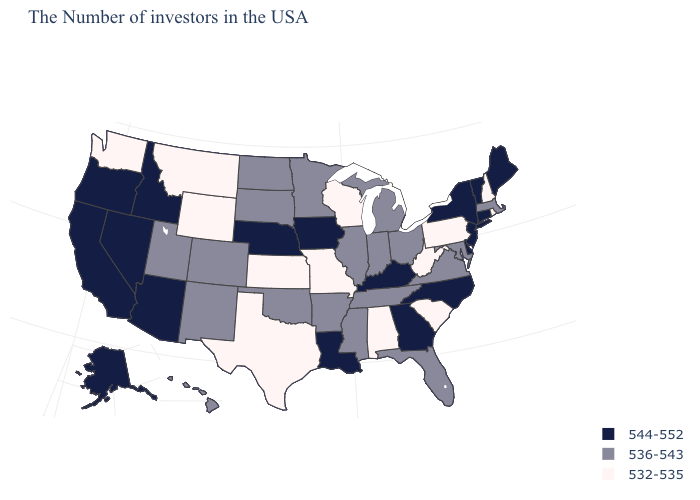Name the states that have a value in the range 532-535?
Answer briefly. Rhode Island, New Hampshire, Pennsylvania, South Carolina, West Virginia, Alabama, Wisconsin, Missouri, Kansas, Texas, Wyoming, Montana, Washington. What is the value of Wisconsin?
Concise answer only. 532-535. Among the states that border Maryland , which have the highest value?
Quick response, please. Delaware. Name the states that have a value in the range 544-552?
Answer briefly. Maine, Vermont, Connecticut, New York, New Jersey, Delaware, North Carolina, Georgia, Kentucky, Louisiana, Iowa, Nebraska, Arizona, Idaho, Nevada, California, Oregon, Alaska. Name the states that have a value in the range 532-535?
Write a very short answer. Rhode Island, New Hampshire, Pennsylvania, South Carolina, West Virginia, Alabama, Wisconsin, Missouri, Kansas, Texas, Wyoming, Montana, Washington. Does the first symbol in the legend represent the smallest category?
Quick response, please. No. What is the highest value in states that border New Jersey?
Concise answer only. 544-552. What is the highest value in states that border Rhode Island?
Keep it brief. 544-552. Name the states that have a value in the range 536-543?
Give a very brief answer. Massachusetts, Maryland, Virginia, Ohio, Florida, Michigan, Indiana, Tennessee, Illinois, Mississippi, Arkansas, Minnesota, Oklahoma, South Dakota, North Dakota, Colorado, New Mexico, Utah, Hawaii. Among the states that border Wisconsin , which have the lowest value?
Short answer required. Michigan, Illinois, Minnesota. Does the first symbol in the legend represent the smallest category?
Be succinct. No. Does New Jersey have the same value as Georgia?
Write a very short answer. Yes. How many symbols are there in the legend?
Be succinct. 3. Name the states that have a value in the range 532-535?
Be succinct. Rhode Island, New Hampshire, Pennsylvania, South Carolina, West Virginia, Alabama, Wisconsin, Missouri, Kansas, Texas, Wyoming, Montana, Washington. What is the lowest value in the USA?
Write a very short answer. 532-535. 